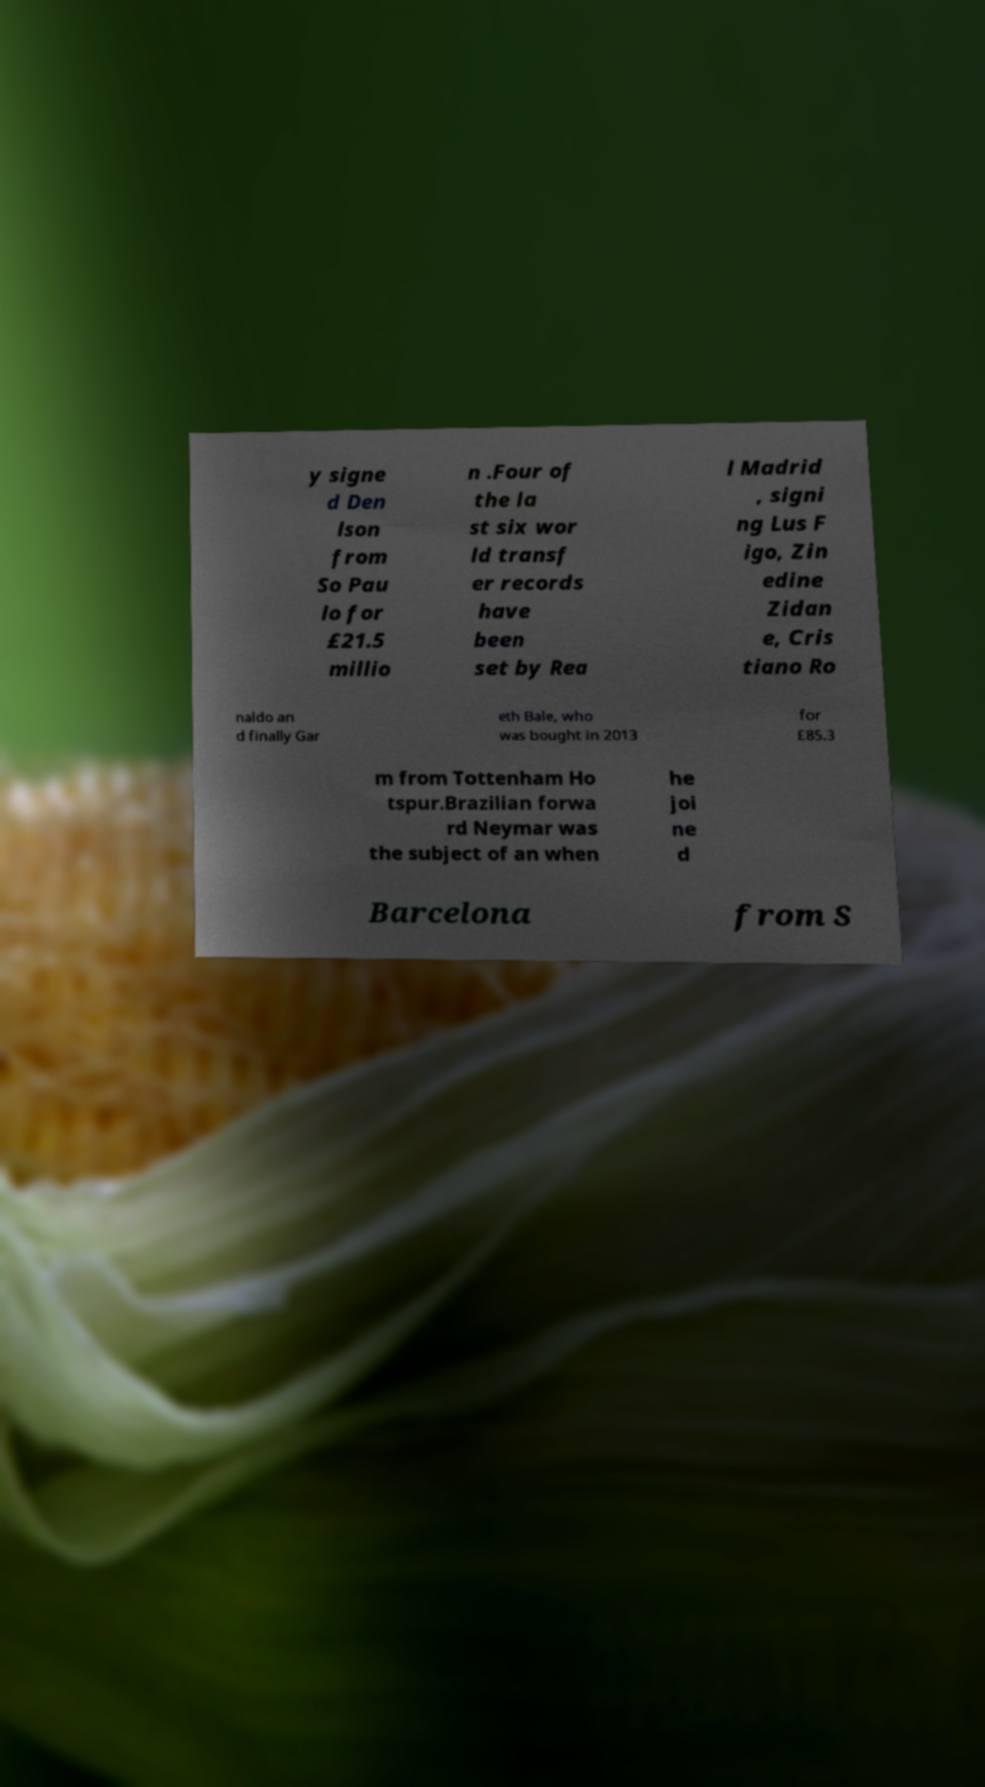Could you extract and type out the text from this image? y signe d Den lson from So Pau lo for £21.5 millio n .Four of the la st six wor ld transf er records have been set by Rea l Madrid , signi ng Lus F igo, Zin edine Zidan e, Cris tiano Ro naldo an d finally Gar eth Bale, who was bought in 2013 for £85.3 m from Tottenham Ho tspur.Brazilian forwa rd Neymar was the subject of an when he joi ne d Barcelona from S 